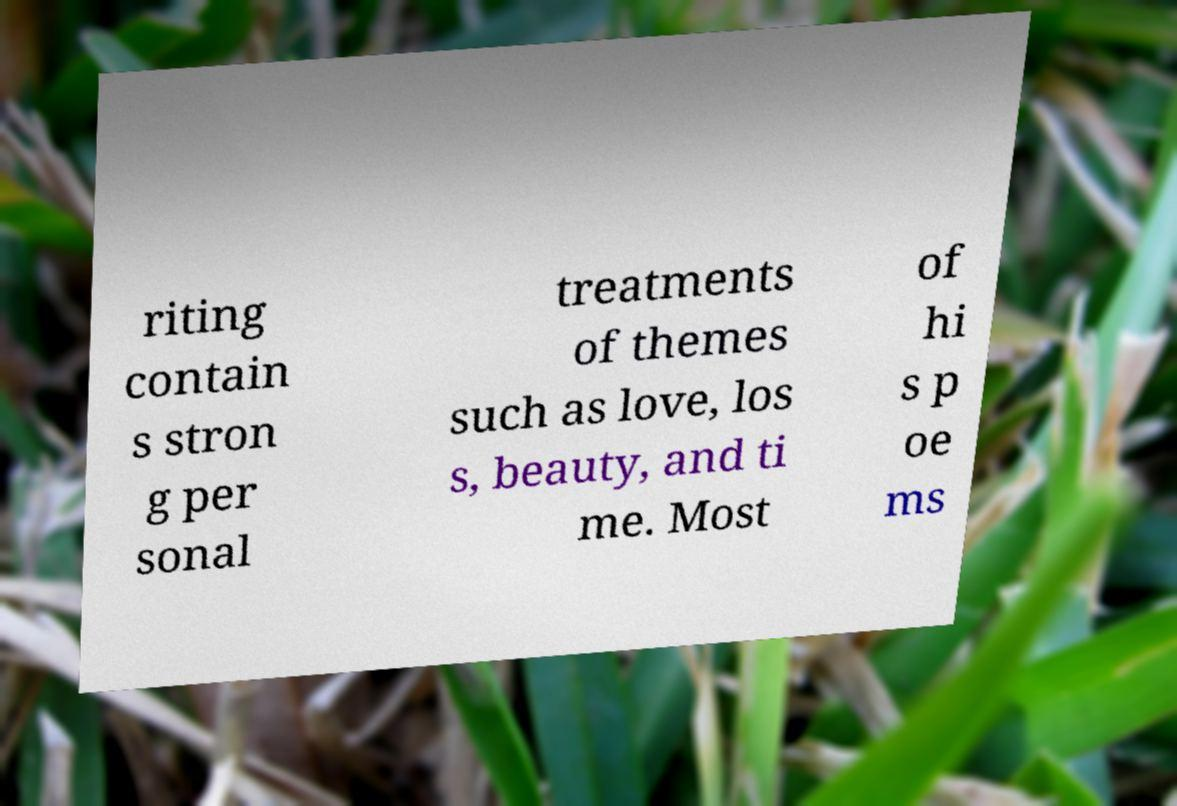There's text embedded in this image that I need extracted. Can you transcribe it verbatim? riting contain s stron g per sonal treatments of themes such as love, los s, beauty, and ti me. Most of hi s p oe ms 